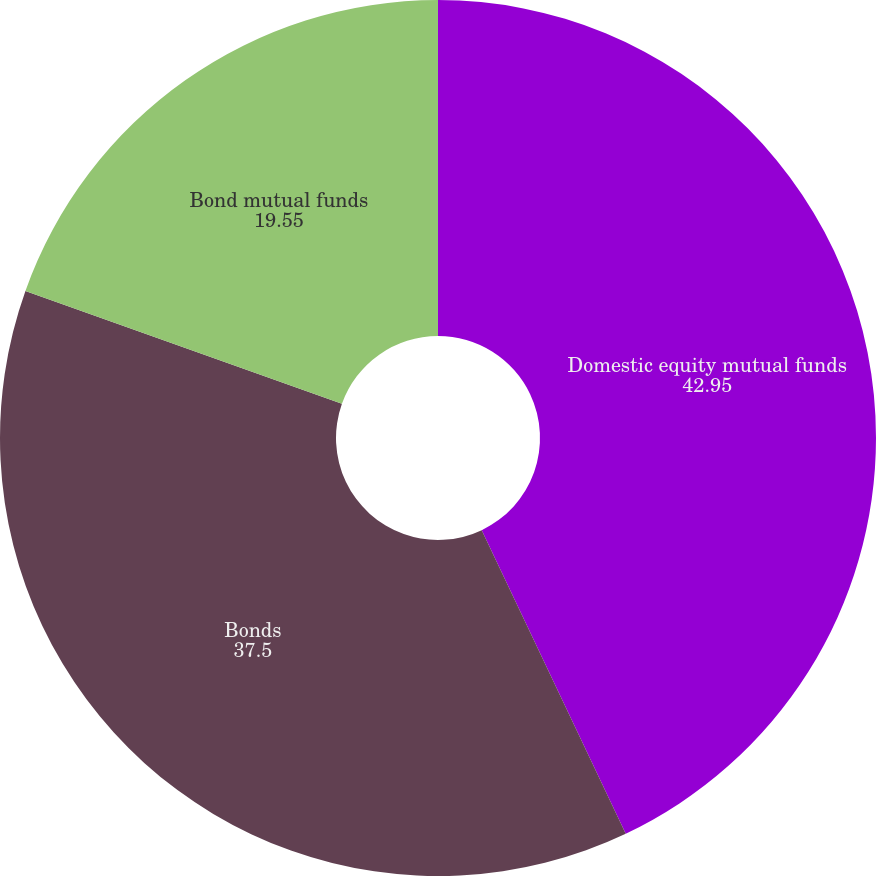<chart> <loc_0><loc_0><loc_500><loc_500><pie_chart><fcel>Domestic equity mutual funds<fcel>Bonds<fcel>Bond mutual funds<nl><fcel>42.95%<fcel>37.5%<fcel>19.55%<nl></chart> 